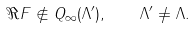Convert formula to latex. <formula><loc_0><loc_0><loc_500><loc_500>\Re F \not \in Q _ { \infty } ( \Lambda ^ { \prime } ) , \quad \Lambda ^ { \prime } \neq \Lambda .</formula> 